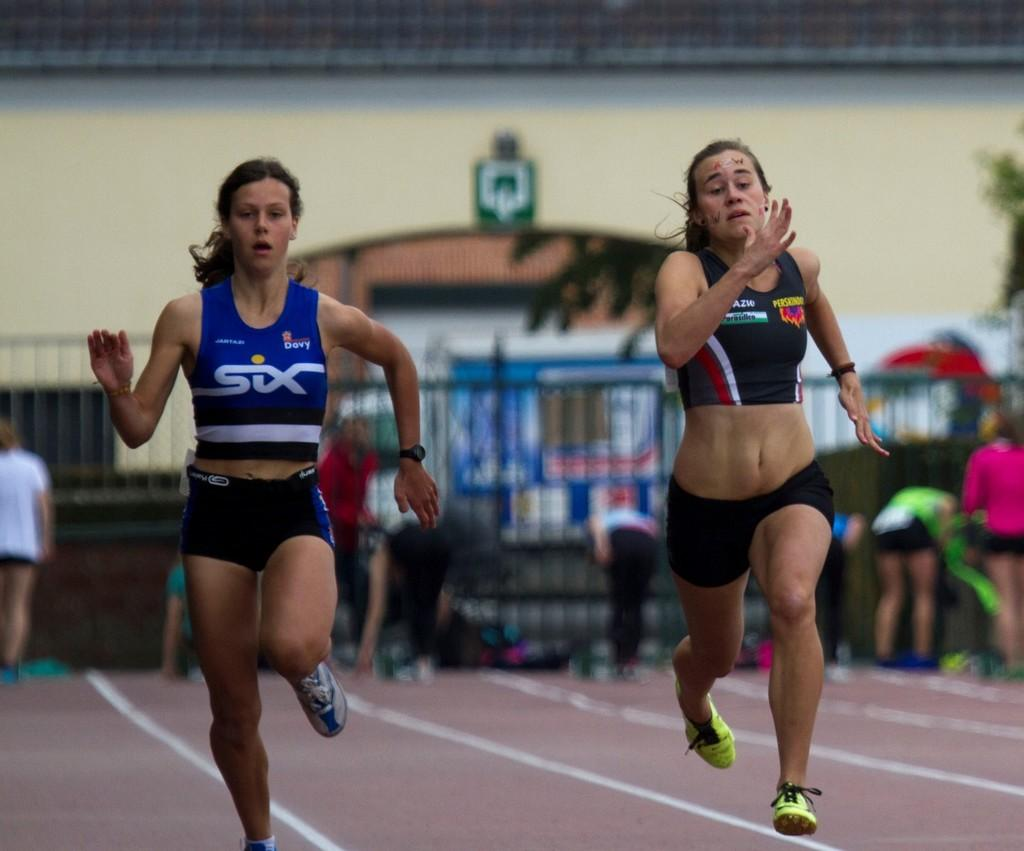<image>
Provide a brief description of the given image. two ladies running anf one with the word six on her shirt 